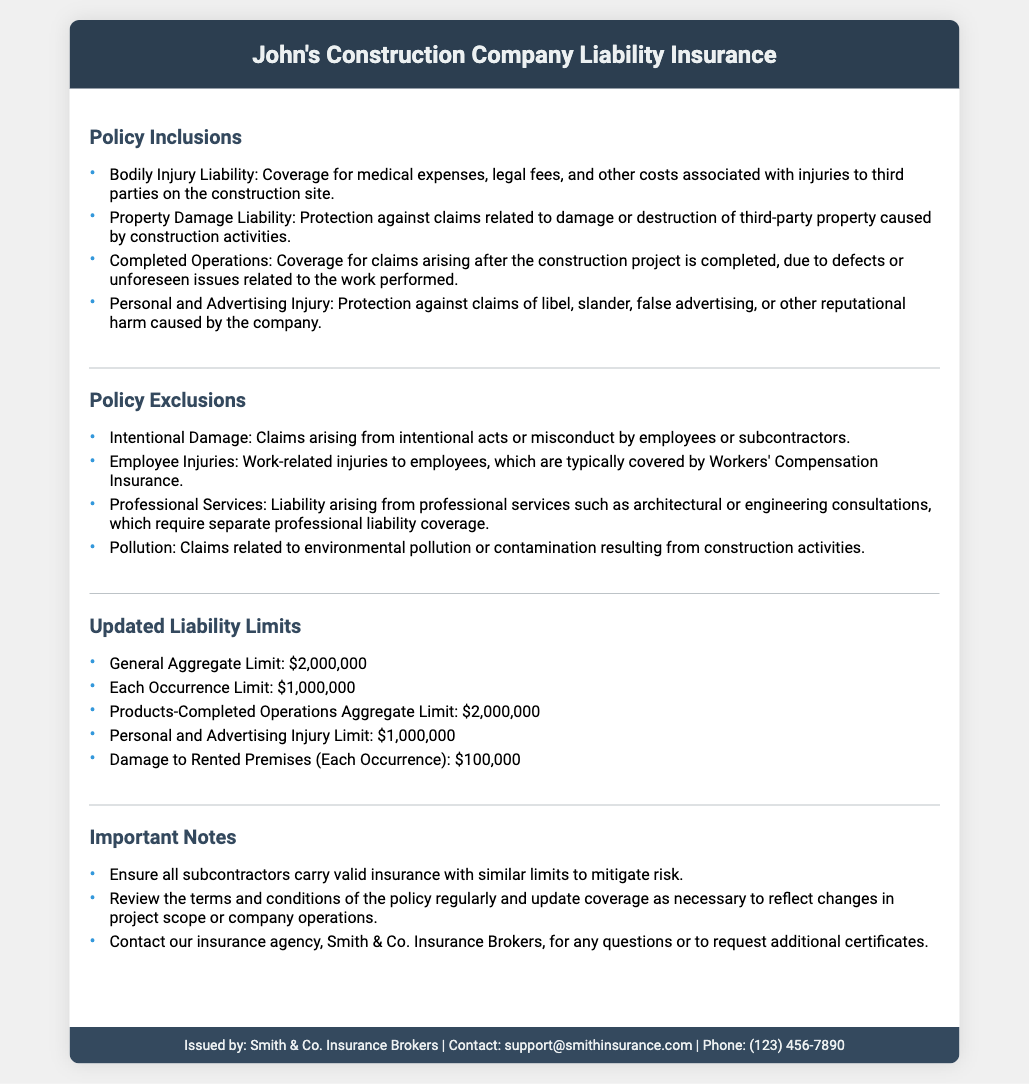What is the General Aggregate Limit? The General Aggregate Limit is the maximum amount that can be paid for all claims during a policy term, which is $2,000,000.
Answer: $2,000,000 What is covered under Bodily Injury Liability? Bodily Injury Liability includes coverage for medical expenses, legal fees, and other costs associated with injuries to third parties on the construction site.
Answer: Medical expenses, legal fees, injuries Which claims are excluded under Pollution? Pollution claims are those related to environmental pollution or contamination resulting from construction activities.
Answer: Environmental pollution What is the Each Occurrence Limit? The Each Occurrence Limit sets the maximum amount the insurer will pay for any single claim, which is $1,000,000.
Answer: $1,000,000 Who issued the insurance certificate? The insurance certificate was issued by Smith & Co. Insurance Brokers.
Answer: Smith & Co. Insurance Brokers What should be done to mitigate risk concerning subcontractors? Ensure all subcontractors carry valid insurance with similar limits.
Answer: Valid insurance Which area is specifically mentioned under Policy Exclusions? Employee Injuries is specifically mentioned under Policy Exclusions as being covered by Workers' Compensation Insurance.
Answer: Employee Injuries What is the limit for Damage to Rented Premises? The limit for Damage to Rented Premises is the maximum that can be claimed for damage to rented property, set at $100,000.
Answer: $100,000 What type of injury is included in Personal and Advertising Injury coverage? Personal and Advertising Injury includes claims of libel, slander, false advertising, or other reputational harm.
Answer: Libel, slander, false advertising 